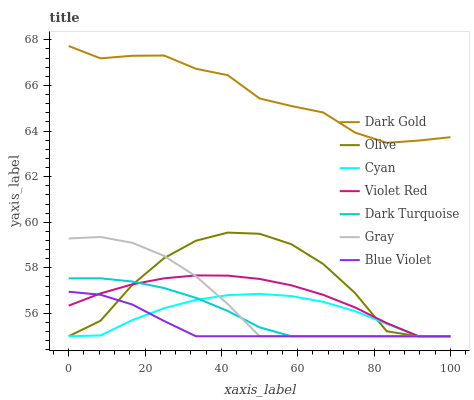Does Blue Violet have the minimum area under the curve?
Answer yes or no. Yes. Does Dark Gold have the maximum area under the curve?
Answer yes or no. Yes. Does Violet Red have the minimum area under the curve?
Answer yes or no. No. Does Violet Red have the maximum area under the curve?
Answer yes or no. No. Is Blue Violet the smoothest?
Answer yes or no. Yes. Is Olive the roughest?
Answer yes or no. Yes. Is Violet Red the smoothest?
Answer yes or no. No. Is Violet Red the roughest?
Answer yes or no. No. Does Gray have the lowest value?
Answer yes or no. Yes. Does Dark Gold have the lowest value?
Answer yes or no. No. Does Dark Gold have the highest value?
Answer yes or no. Yes. Does Violet Red have the highest value?
Answer yes or no. No. Is Blue Violet less than Dark Gold?
Answer yes or no. Yes. Is Dark Gold greater than Gray?
Answer yes or no. Yes. Does Dark Turquoise intersect Gray?
Answer yes or no. Yes. Is Dark Turquoise less than Gray?
Answer yes or no. No. Is Dark Turquoise greater than Gray?
Answer yes or no. No. Does Blue Violet intersect Dark Gold?
Answer yes or no. No. 